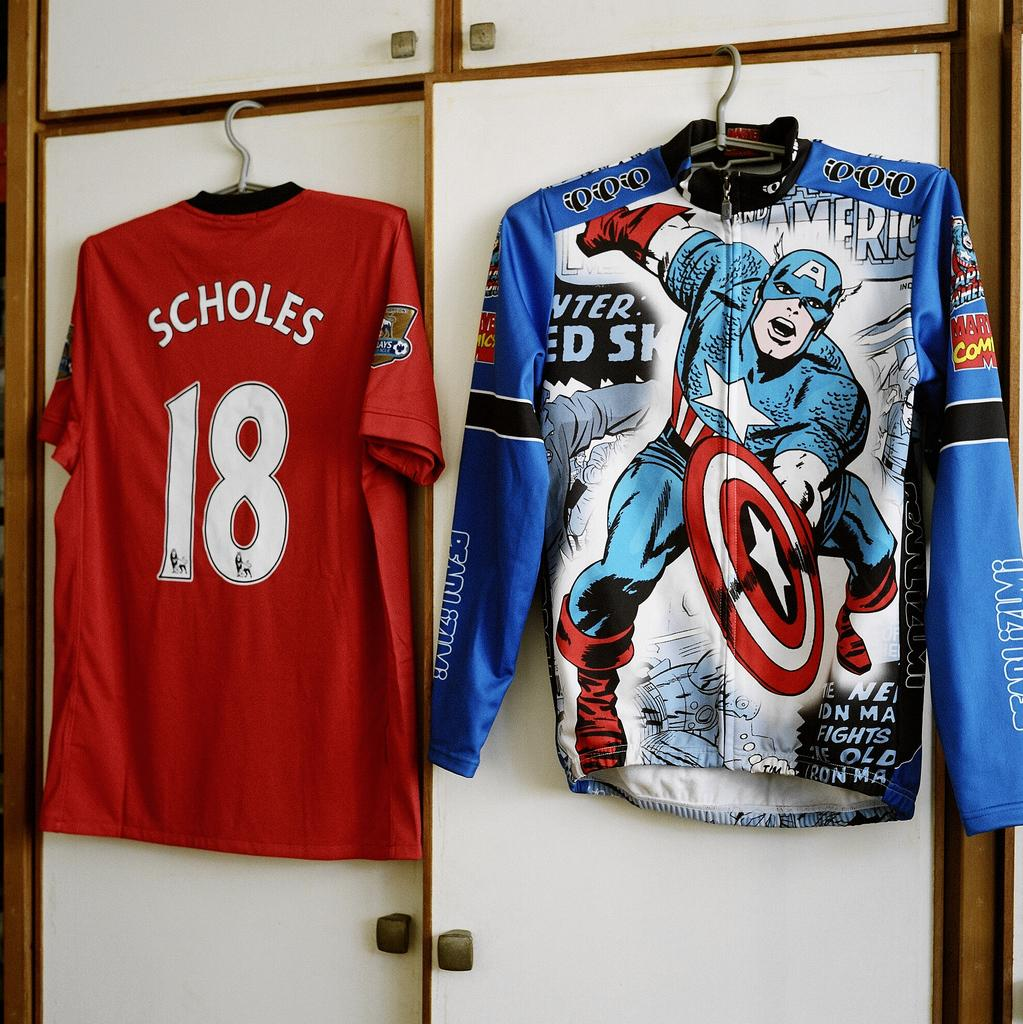<image>
Summarize the visual content of the image. A shirt with Captain America on it hangs next to another shirt with the number 18 on it. 